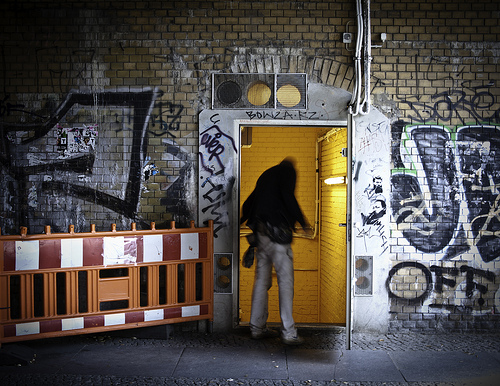Please provide a short description for this region: [0.5, 0.42, 0.63, 0.83]. This region captures a hurried man entering a yellow-door building, possibly escaping the chaotic street art that surrounds him. 